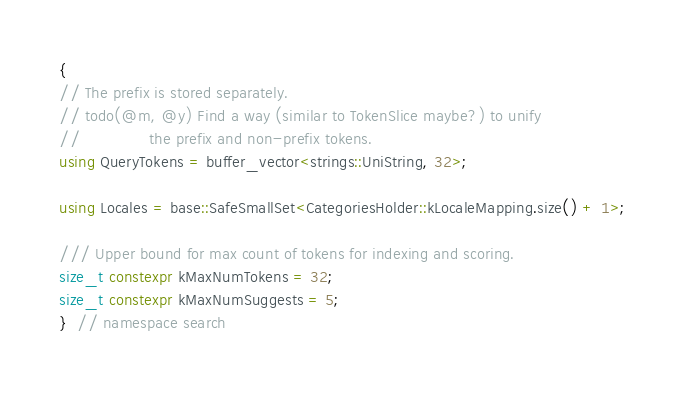<code> <loc_0><loc_0><loc_500><loc_500><_C++_>{
// The prefix is stored separately.
// todo(@m, @y) Find a way (similar to TokenSlice maybe?) to unify
//              the prefix and non-prefix tokens.
using QueryTokens = buffer_vector<strings::UniString, 32>;

using Locales = base::SafeSmallSet<CategoriesHolder::kLocaleMapping.size() + 1>;

/// Upper bound for max count of tokens for indexing and scoring.
size_t constexpr kMaxNumTokens = 32;
size_t constexpr kMaxNumSuggests = 5;
}  // namespace search
</code> 